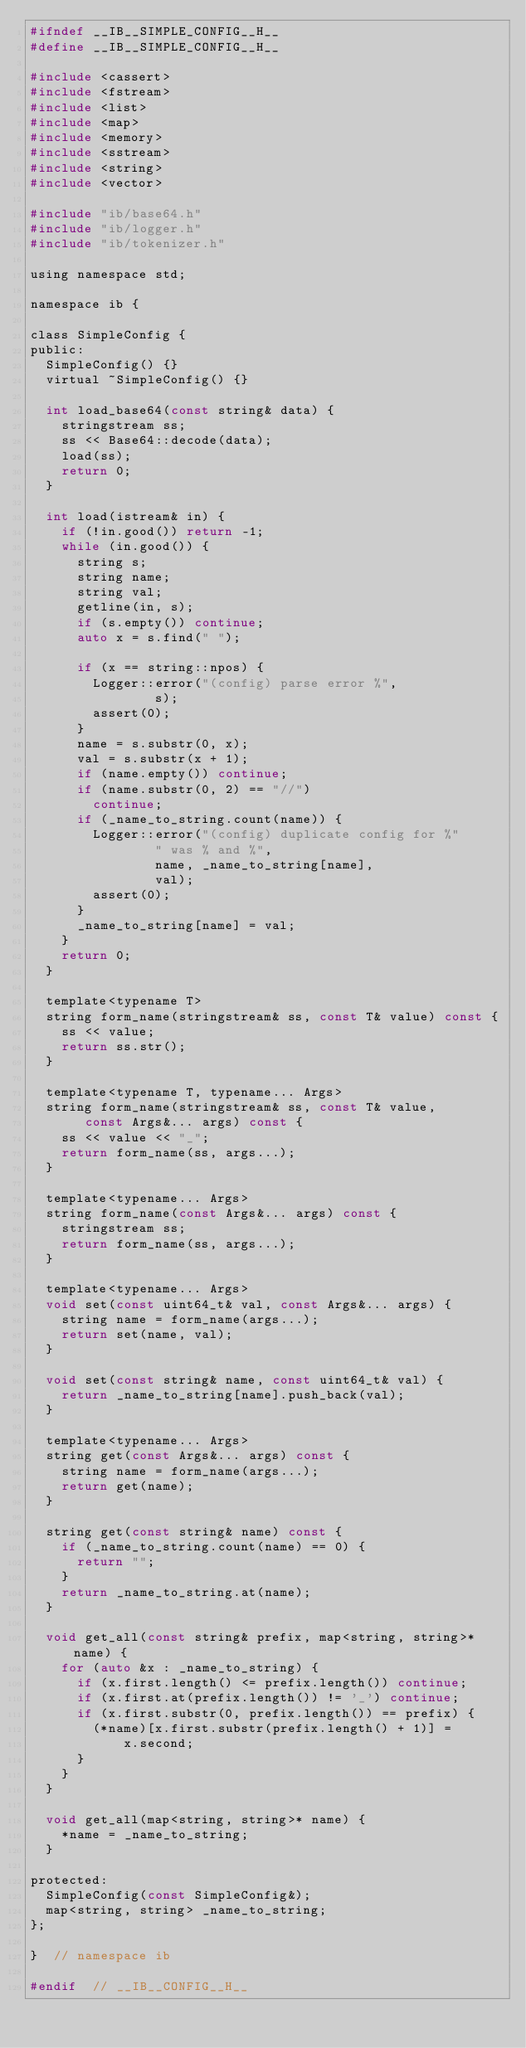Convert code to text. <code><loc_0><loc_0><loc_500><loc_500><_C_>#ifndef __IB__SIMPLE_CONFIG__H__
#define __IB__SIMPLE_CONFIG__H__

#include <cassert>
#include <fstream>
#include <list>
#include <map>
#include <memory>
#include <sstream>
#include <string>
#include <vector>

#include "ib/base64.h"
#include "ib/logger.h"
#include "ib/tokenizer.h"

using namespace std;

namespace ib {

class SimpleConfig {
public:
	SimpleConfig() {}
	virtual ~SimpleConfig() {}

	int load_base64(const string& data) {
		stringstream ss;
		ss << Base64::decode(data);
		load(ss);
		return 0;
	}

	int load(istream& in) {
		if (!in.good()) return -1;
		while (in.good()) {
			string s;
			string name;
			string val;
			getline(in, s);
			if (s.empty()) continue;
			auto x = s.find(" ");

			if (x == string::npos) {
				Logger::error("(config) parse error %",
					      s);
				assert(0);
			}
			name = s.substr(0, x);
			val = s.substr(x + 1);
			if (name.empty()) continue;
			if (name.substr(0, 2) == "//")
				continue;
			if (_name_to_string.count(name)) {
				Logger::error("(config) duplicate config for %"
					      " was % and %",
					      name, _name_to_string[name],
					      val);
				assert(0);
			}
			_name_to_string[name] = val;
		}
		return 0;
	}

	template<typename T>
	string form_name(stringstream& ss, const T& value) const {
		ss << value;
		return ss.str();
	}

	template<typename T, typename... Args>
	string form_name(stringstream& ss, const T& value,
			 const Args&... args) const {
		ss << value << "_";
		return form_name(ss, args...);
	}

	template<typename... Args>
	string form_name(const Args&... args) const {
		stringstream ss;
		return form_name(ss, args...);
	}

	template<typename... Args>
	void set(const uint64_t& val, const Args&... args) {
		string name = form_name(args...);
		return set(name, val);
	}

	void set(const string& name, const uint64_t& val) {
		return _name_to_string[name].push_back(val);
	}

	template<typename... Args>
	string get(const Args&... args) const {
		string name = form_name(args...);
		return get(name);
	}

	string get(const string& name) const {
		if (_name_to_string.count(name) == 0) {
			return "";
		}
		return _name_to_string.at(name);
	}

	void get_all(const string& prefix, map<string, string>* name) {
		for (auto &x : _name_to_string) {
			if (x.first.length() <= prefix.length()) continue;
			if (x.first.at(prefix.length()) != '_') continue;
			if (x.first.substr(0, prefix.length()) == prefix) {
				(*name)[x.first.substr(prefix.length() + 1)] =
				    x.second;
			}
		}
	}

	void get_all(map<string, string>* name) {
		*name = _name_to_string;
	}

protected:
	SimpleConfig(const SimpleConfig&);
	map<string, string> _name_to_string;
};

}  // namespace ib

#endif  // __IB__CONFIG__H__
</code> 